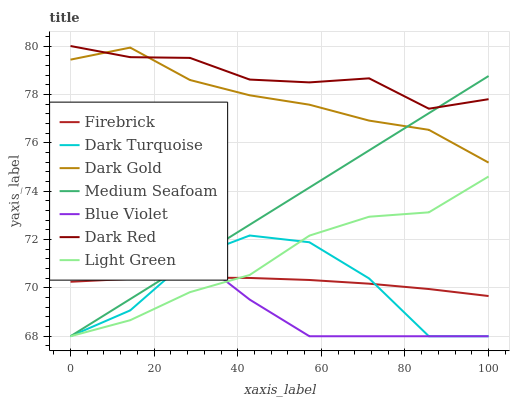Does Blue Violet have the minimum area under the curve?
Answer yes or no. Yes. Does Dark Red have the maximum area under the curve?
Answer yes or no. Yes. Does Dark Turquoise have the minimum area under the curve?
Answer yes or no. No. Does Dark Turquoise have the maximum area under the curve?
Answer yes or no. No. Is Medium Seafoam the smoothest?
Answer yes or no. Yes. Is Dark Turquoise the roughest?
Answer yes or no. Yes. Is Firebrick the smoothest?
Answer yes or no. No. Is Firebrick the roughest?
Answer yes or no. No. Does Dark Turquoise have the lowest value?
Answer yes or no. Yes. Does Firebrick have the lowest value?
Answer yes or no. No. Does Dark Red have the highest value?
Answer yes or no. Yes. Does Dark Turquoise have the highest value?
Answer yes or no. No. Is Dark Turquoise less than Dark Gold?
Answer yes or no. Yes. Is Dark Gold greater than Dark Turquoise?
Answer yes or no. Yes. Does Medium Seafoam intersect Blue Violet?
Answer yes or no. Yes. Is Medium Seafoam less than Blue Violet?
Answer yes or no. No. Is Medium Seafoam greater than Blue Violet?
Answer yes or no. No. Does Dark Turquoise intersect Dark Gold?
Answer yes or no. No. 